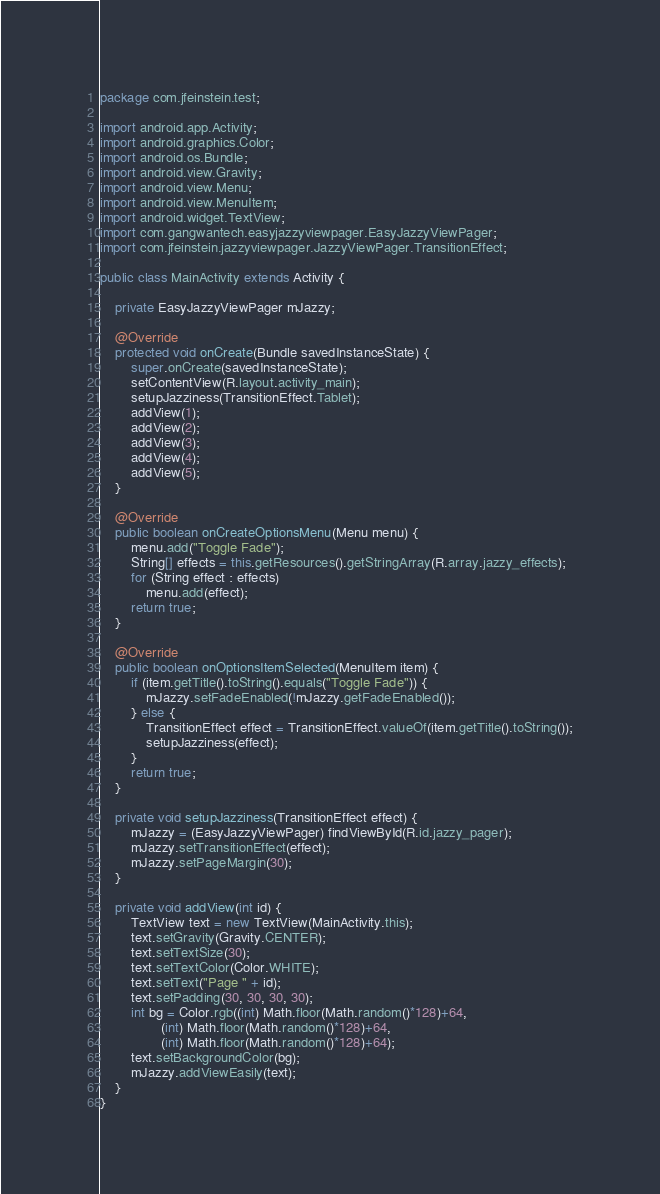Convert code to text. <code><loc_0><loc_0><loc_500><loc_500><_Java_>package com.jfeinstein.test;

import android.app.Activity;
import android.graphics.Color;
import android.os.Bundle;
import android.view.Gravity;
import android.view.Menu;
import android.view.MenuItem;
import android.widget.TextView;
import com.gangwantech.easyjazzyviewpager.EasyJazzyViewPager;
import com.jfeinstein.jazzyviewpager.JazzyViewPager.TransitionEffect;

public class MainActivity extends Activity {

	private EasyJazzyViewPager mJazzy;

	@Override
	protected void onCreate(Bundle savedInstanceState) {
		super.onCreate(savedInstanceState);
		setContentView(R.layout.activity_main);
		setupJazziness(TransitionEffect.Tablet);
		addView(1);
		addView(2);
		addView(3);
		addView(4);
		addView(5);
	}

	@Override
	public boolean onCreateOptionsMenu(Menu menu) {
		menu.add("Toggle Fade");
		String[] effects = this.getResources().getStringArray(R.array.jazzy_effects);
		for (String effect : effects)
			menu.add(effect);
		return true;
	}

	@Override
	public boolean onOptionsItemSelected(MenuItem item) {
		if (item.getTitle().toString().equals("Toggle Fade")) {
			mJazzy.setFadeEnabled(!mJazzy.getFadeEnabled());
		} else {
			TransitionEffect effect = TransitionEffect.valueOf(item.getTitle().toString());
			setupJazziness(effect);
		}
		return true;
	}

	private void setupJazziness(TransitionEffect effect) {
		mJazzy = (EasyJazzyViewPager) findViewById(R.id.jazzy_pager);
		mJazzy.setTransitionEffect(effect);
		mJazzy.setPageMargin(30);
	}

	private void addView(int id) {
		TextView text = new TextView(MainActivity.this);
		text.setGravity(Gravity.CENTER);
		text.setTextSize(30);
		text.setTextColor(Color.WHITE);
		text.setText("Page " + id);
		text.setPadding(30, 30, 30, 30);
		int bg = Color.rgb((int) Math.floor(Math.random()*128)+64,
				(int) Math.floor(Math.random()*128)+64,
				(int) Math.floor(Math.random()*128)+64);
		text.setBackgroundColor(bg);
		mJazzy.addViewEasily(text);
	}
}
</code> 